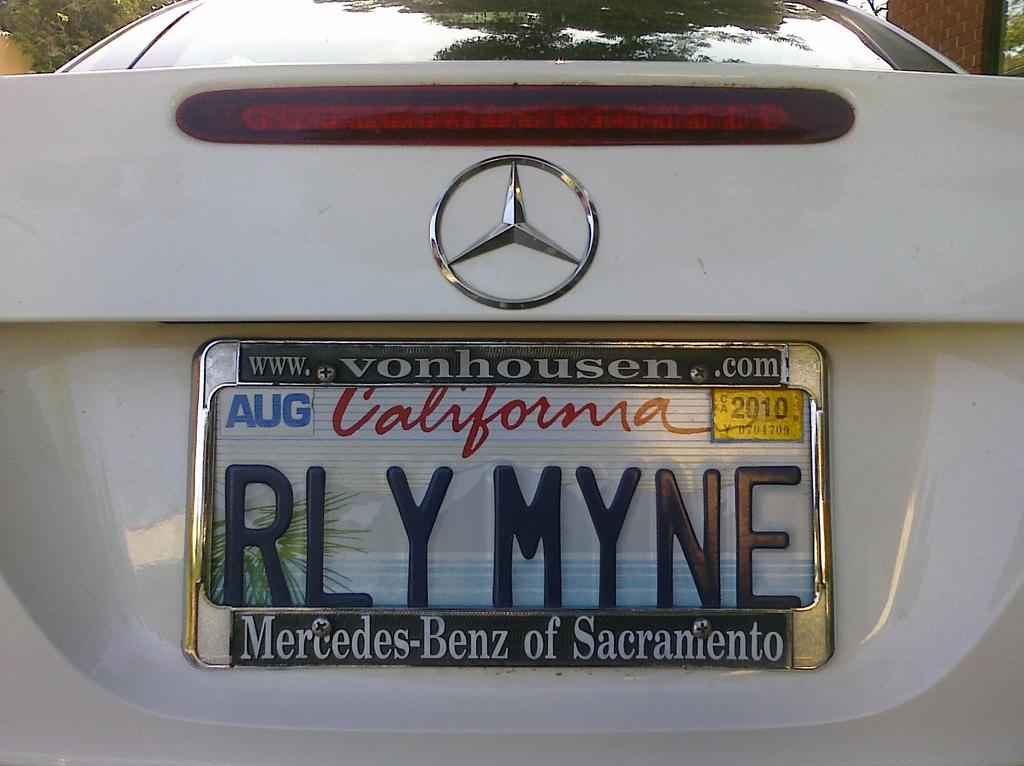Provide a one-sentence caption for the provided image. A white Mercedes-Benz with a personalized plate was purchased at a Sacramento dealership. 